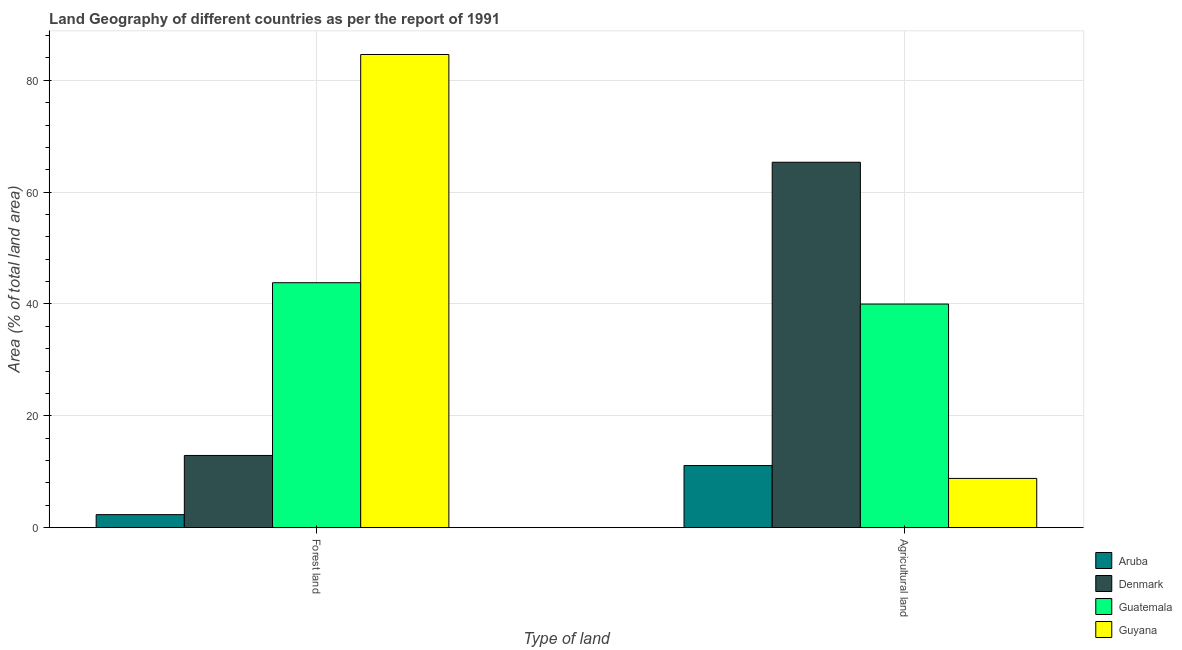How many different coloured bars are there?
Offer a terse response. 4. How many groups of bars are there?
Offer a very short reply. 2. How many bars are there on the 2nd tick from the left?
Ensure brevity in your answer.  4. How many bars are there on the 1st tick from the right?
Keep it short and to the point. 4. What is the label of the 1st group of bars from the left?
Your answer should be compact. Forest land. What is the percentage of land area under forests in Denmark?
Provide a succinct answer. 12.91. Across all countries, what is the maximum percentage of land area under forests?
Make the answer very short. 84.61. Across all countries, what is the minimum percentage of land area under forests?
Your response must be concise. 2.33. In which country was the percentage of land area under forests maximum?
Ensure brevity in your answer.  Guyana. In which country was the percentage of land area under agriculture minimum?
Offer a very short reply. Guyana. What is the total percentage of land area under agriculture in the graph?
Make the answer very short. 125.25. What is the difference between the percentage of land area under forests in Guyana and that in Guatemala?
Keep it short and to the point. 40.81. What is the difference between the percentage of land area under forests in Denmark and the percentage of land area under agriculture in Guatemala?
Provide a succinct answer. -27.07. What is the average percentage of land area under forests per country?
Ensure brevity in your answer.  35.92. What is the difference between the percentage of land area under forests and percentage of land area under agriculture in Guatemala?
Offer a very short reply. 3.82. What is the ratio of the percentage of land area under agriculture in Guyana to that in Denmark?
Offer a terse response. 0.13. Is the percentage of land area under forests in Guyana less than that in Guatemala?
Your answer should be very brief. No. In how many countries, is the percentage of land area under forests greater than the average percentage of land area under forests taken over all countries?
Ensure brevity in your answer.  2. What does the 2nd bar from the left in Agricultural land represents?
Your answer should be very brief. Denmark. What does the 3rd bar from the right in Agricultural land represents?
Make the answer very short. Denmark. How many bars are there?
Give a very brief answer. 8. Are all the bars in the graph horizontal?
Your answer should be very brief. No. How many countries are there in the graph?
Make the answer very short. 4. What is the difference between two consecutive major ticks on the Y-axis?
Your answer should be very brief. 20. Does the graph contain any zero values?
Provide a short and direct response. No. Does the graph contain grids?
Keep it short and to the point. Yes. Where does the legend appear in the graph?
Your answer should be compact. Bottom right. What is the title of the graph?
Make the answer very short. Land Geography of different countries as per the report of 1991. Does "Georgia" appear as one of the legend labels in the graph?
Provide a succinct answer. No. What is the label or title of the X-axis?
Your response must be concise. Type of land. What is the label or title of the Y-axis?
Make the answer very short. Area (% of total land area). What is the Area (% of total land area) in Aruba in Forest land?
Your response must be concise. 2.33. What is the Area (% of total land area) of Denmark in Forest land?
Your answer should be compact. 12.91. What is the Area (% of total land area) of Guatemala in Forest land?
Keep it short and to the point. 43.8. What is the Area (% of total land area) in Guyana in Forest land?
Your answer should be very brief. 84.61. What is the Area (% of total land area) of Aruba in Agricultural land?
Provide a short and direct response. 11.11. What is the Area (% of total land area) in Denmark in Agricultural land?
Ensure brevity in your answer.  65.35. What is the Area (% of total land area) of Guatemala in Agricultural land?
Offer a terse response. 39.99. What is the Area (% of total land area) of Guyana in Agricultural land?
Offer a very short reply. 8.81. Across all Type of land, what is the maximum Area (% of total land area) of Aruba?
Give a very brief answer. 11.11. Across all Type of land, what is the maximum Area (% of total land area) in Denmark?
Your answer should be very brief. 65.35. Across all Type of land, what is the maximum Area (% of total land area) of Guatemala?
Your answer should be compact. 43.8. Across all Type of land, what is the maximum Area (% of total land area) of Guyana?
Provide a short and direct response. 84.61. Across all Type of land, what is the minimum Area (% of total land area) of Aruba?
Offer a terse response. 2.33. Across all Type of land, what is the minimum Area (% of total land area) in Denmark?
Provide a succinct answer. 12.91. Across all Type of land, what is the minimum Area (% of total land area) in Guatemala?
Your answer should be compact. 39.99. Across all Type of land, what is the minimum Area (% of total land area) of Guyana?
Keep it short and to the point. 8.81. What is the total Area (% of total land area) of Aruba in the graph?
Offer a terse response. 13.44. What is the total Area (% of total land area) in Denmark in the graph?
Give a very brief answer. 78.26. What is the total Area (% of total land area) of Guatemala in the graph?
Your answer should be compact. 83.79. What is the total Area (% of total land area) of Guyana in the graph?
Offer a very short reply. 93.42. What is the difference between the Area (% of total land area) of Aruba in Forest land and that in Agricultural land?
Offer a terse response. -8.78. What is the difference between the Area (% of total land area) in Denmark in Forest land and that in Agricultural land?
Give a very brief answer. -52.43. What is the difference between the Area (% of total land area) in Guatemala in Forest land and that in Agricultural land?
Keep it short and to the point. 3.82. What is the difference between the Area (% of total land area) in Guyana in Forest land and that in Agricultural land?
Provide a succinct answer. 75.8. What is the difference between the Area (% of total land area) of Aruba in Forest land and the Area (% of total land area) of Denmark in Agricultural land?
Offer a very short reply. -63.01. What is the difference between the Area (% of total land area) in Aruba in Forest land and the Area (% of total land area) in Guatemala in Agricultural land?
Offer a very short reply. -37.65. What is the difference between the Area (% of total land area) in Aruba in Forest land and the Area (% of total land area) in Guyana in Agricultural land?
Provide a short and direct response. -6.48. What is the difference between the Area (% of total land area) in Denmark in Forest land and the Area (% of total land area) in Guatemala in Agricultural land?
Your answer should be very brief. -27.07. What is the difference between the Area (% of total land area) in Denmark in Forest land and the Area (% of total land area) in Guyana in Agricultural land?
Provide a succinct answer. 4.11. What is the difference between the Area (% of total land area) in Guatemala in Forest land and the Area (% of total land area) in Guyana in Agricultural land?
Provide a short and direct response. 34.99. What is the average Area (% of total land area) of Aruba per Type of land?
Provide a short and direct response. 6.72. What is the average Area (% of total land area) of Denmark per Type of land?
Give a very brief answer. 39.13. What is the average Area (% of total land area) in Guatemala per Type of land?
Give a very brief answer. 41.9. What is the average Area (% of total land area) of Guyana per Type of land?
Your response must be concise. 46.71. What is the difference between the Area (% of total land area) in Aruba and Area (% of total land area) in Denmark in Forest land?
Keep it short and to the point. -10.58. What is the difference between the Area (% of total land area) in Aruba and Area (% of total land area) in Guatemala in Forest land?
Offer a terse response. -41.47. What is the difference between the Area (% of total land area) of Aruba and Area (% of total land area) of Guyana in Forest land?
Provide a succinct answer. -82.28. What is the difference between the Area (% of total land area) in Denmark and Area (% of total land area) in Guatemala in Forest land?
Your answer should be very brief. -30.89. What is the difference between the Area (% of total land area) of Denmark and Area (% of total land area) of Guyana in Forest land?
Your answer should be compact. -71.7. What is the difference between the Area (% of total land area) of Guatemala and Area (% of total land area) of Guyana in Forest land?
Give a very brief answer. -40.81. What is the difference between the Area (% of total land area) of Aruba and Area (% of total land area) of Denmark in Agricultural land?
Your answer should be compact. -54.23. What is the difference between the Area (% of total land area) in Aruba and Area (% of total land area) in Guatemala in Agricultural land?
Offer a terse response. -28.88. What is the difference between the Area (% of total land area) of Aruba and Area (% of total land area) of Guyana in Agricultural land?
Make the answer very short. 2.3. What is the difference between the Area (% of total land area) of Denmark and Area (% of total land area) of Guatemala in Agricultural land?
Offer a terse response. 25.36. What is the difference between the Area (% of total land area) of Denmark and Area (% of total land area) of Guyana in Agricultural land?
Your answer should be compact. 56.54. What is the difference between the Area (% of total land area) in Guatemala and Area (% of total land area) in Guyana in Agricultural land?
Your answer should be very brief. 31.18. What is the ratio of the Area (% of total land area) of Aruba in Forest land to that in Agricultural land?
Your answer should be very brief. 0.21. What is the ratio of the Area (% of total land area) of Denmark in Forest land to that in Agricultural land?
Keep it short and to the point. 0.2. What is the ratio of the Area (% of total land area) in Guatemala in Forest land to that in Agricultural land?
Offer a terse response. 1.1. What is the ratio of the Area (% of total land area) of Guyana in Forest land to that in Agricultural land?
Your answer should be very brief. 9.61. What is the difference between the highest and the second highest Area (% of total land area) of Aruba?
Offer a terse response. 8.78. What is the difference between the highest and the second highest Area (% of total land area) in Denmark?
Your answer should be compact. 52.43. What is the difference between the highest and the second highest Area (% of total land area) in Guatemala?
Provide a succinct answer. 3.82. What is the difference between the highest and the second highest Area (% of total land area) of Guyana?
Provide a succinct answer. 75.8. What is the difference between the highest and the lowest Area (% of total land area) in Aruba?
Your answer should be compact. 8.78. What is the difference between the highest and the lowest Area (% of total land area) in Denmark?
Make the answer very short. 52.43. What is the difference between the highest and the lowest Area (% of total land area) in Guatemala?
Offer a terse response. 3.82. What is the difference between the highest and the lowest Area (% of total land area) in Guyana?
Make the answer very short. 75.8. 